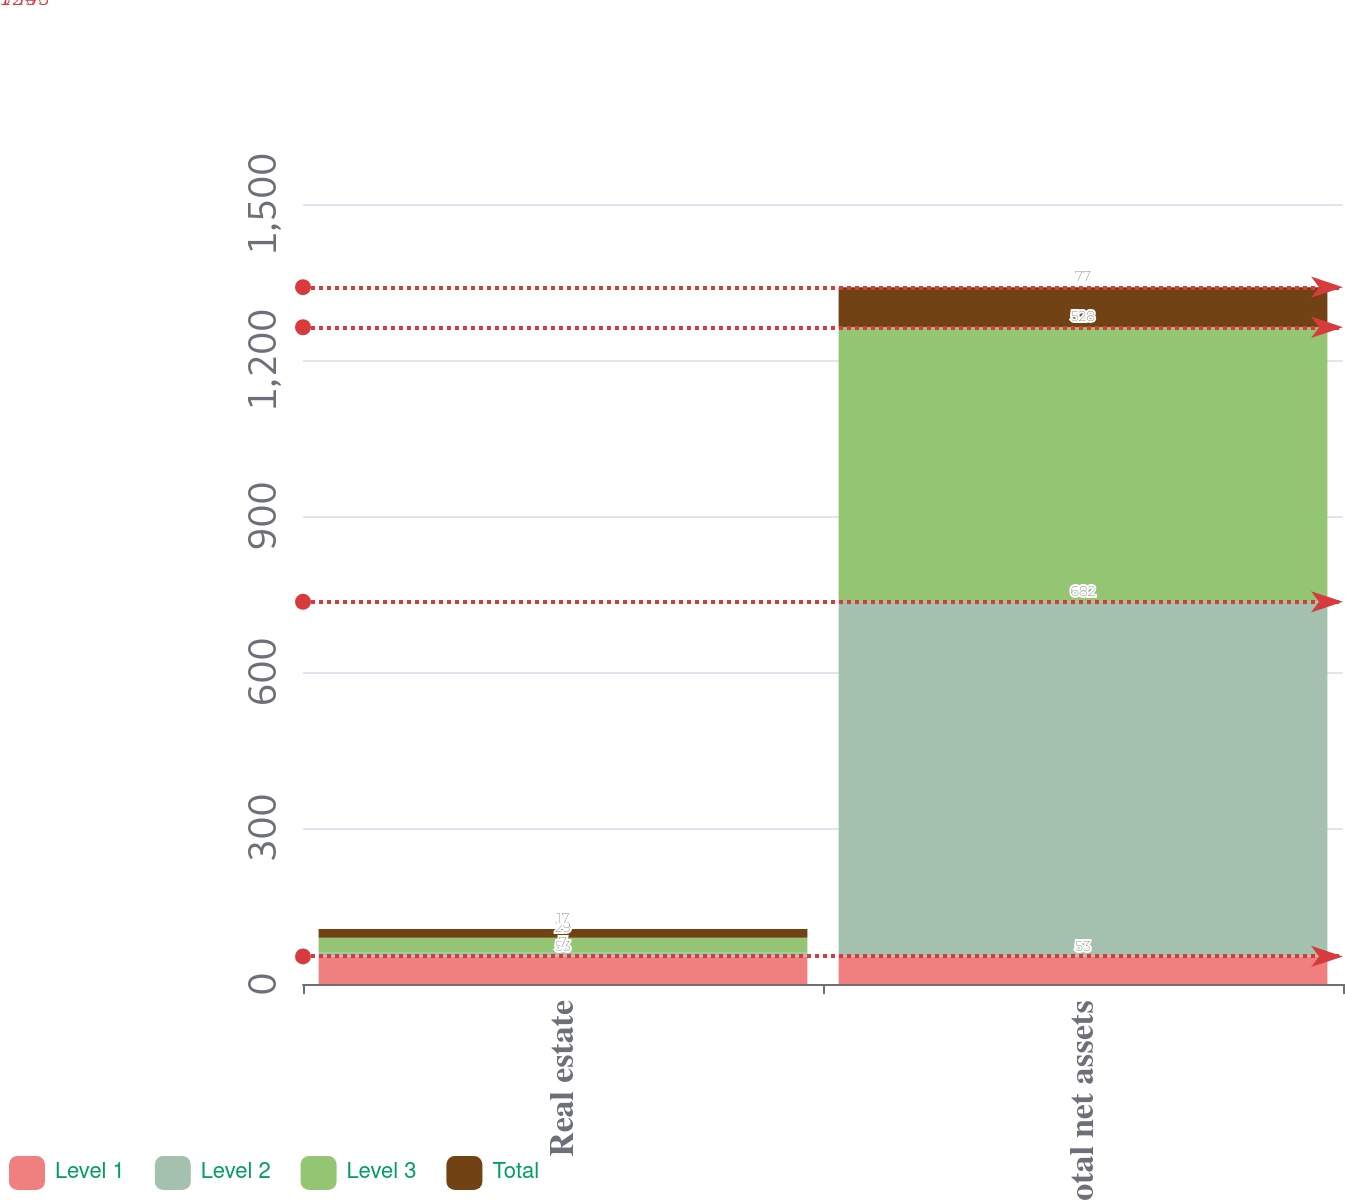<chart> <loc_0><loc_0><loc_500><loc_500><stacked_bar_chart><ecel><fcel>Real estate<fcel>Total net assets<nl><fcel>Level 1<fcel>53<fcel>53<nl><fcel>Level 2<fcel>7<fcel>682<nl><fcel>Level 3<fcel>29<fcel>528<nl><fcel>Total<fcel>17<fcel>77<nl></chart> 